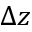<formula> <loc_0><loc_0><loc_500><loc_500>\Delta z</formula> 